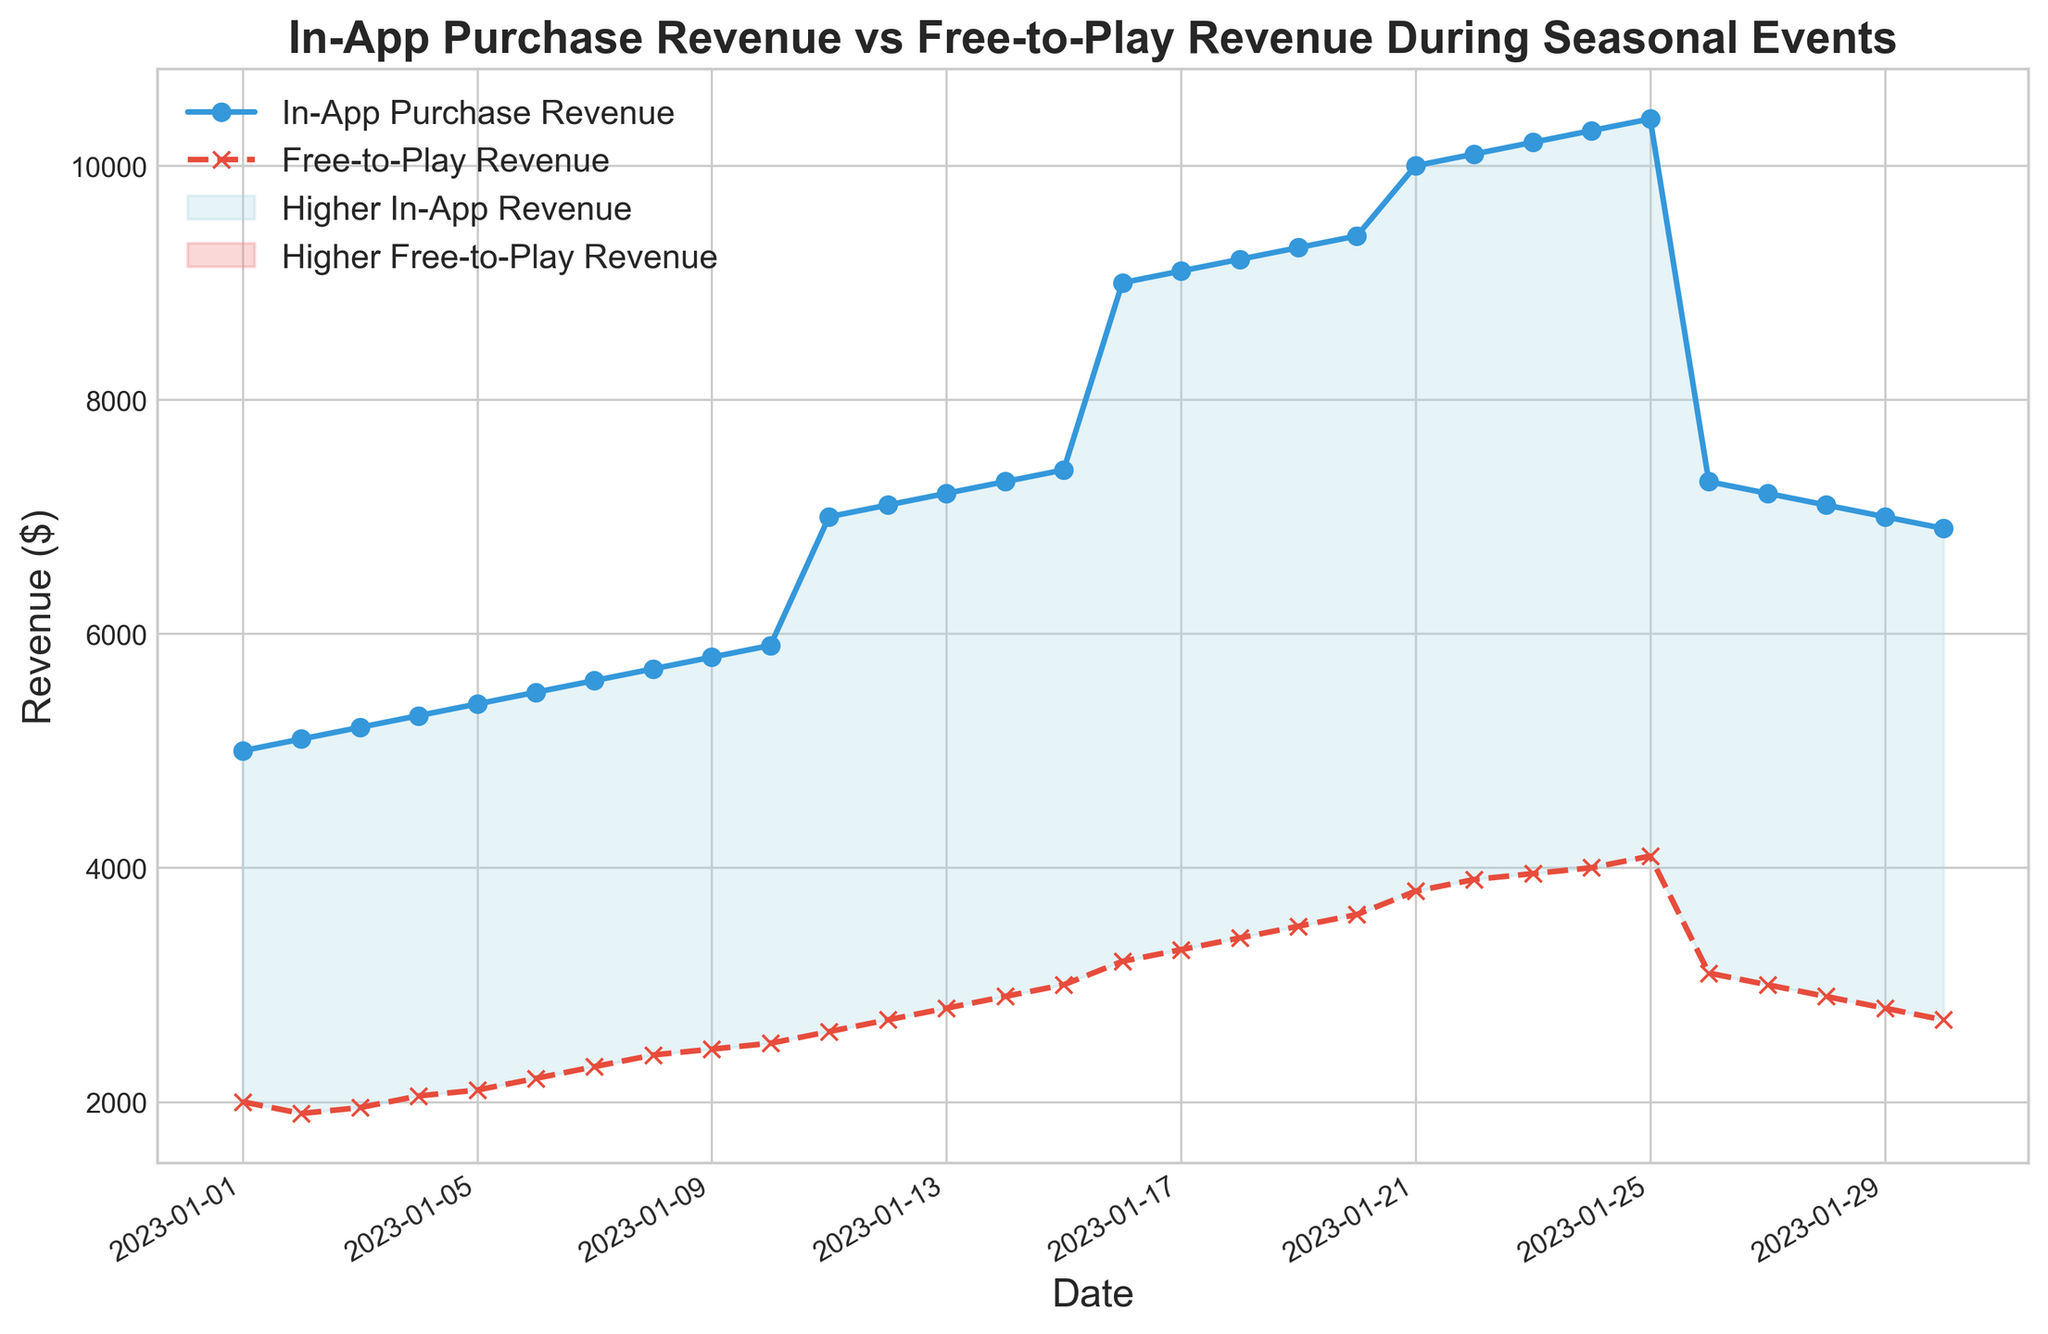What is the highest in-app purchase revenue recorded during the period? The highest point on the in-app purchase revenue line represents the maximum revenue. This occurs on January 24th with a revenue of $10,300.
Answer: $10,300 What is the total revenue from both in-app purchases and free-to-play on January 21st? To find the total revenue for January 21st, sum the in-app purchase revenue and the free-to-play revenue for that date. The in-app purchase revenue is $10,000, and the free-to-play revenue is $3,800. So, the total revenue is $10,000 + $3,800 = $13,800.
Answer: $13,800 On which dates does the in-app purchase revenue exceed the free-to-play revenue by the greatest amount? The greatest difference is visually where the blue shaded area between the lines is widest. This appears around January 16th to January 25th. For instance, on January 24th, the in-app purchase revenue is $10,300 and the free-to-play revenue is $4,000, yielding a difference of $6,300.
Answer: January 24th For how many days did free-to-play revenue decrease consecutively after January 26th? From January 26th onwards, the free-to-play revenue starts decreasing day by day. Specifically, it decreases from January 26th ($3,100) to January 30th ($2,700), making it a decline over 5 consecutive days.
Answer: 5 days How does the average in-app purchase revenue compare to the average free-to-play revenue over the entire period? To find the averages, sum the total in-app purchase revenue and total free-to-play revenue, then divide by the number of days. The total in-app purchase is $210,200 over 30 days, so the average is $210,200 / 30 = $7,007. The total free-to-play revenue is $95,650 over 30 days, so the average is $95,650 / 30 = $3,188. The in-app purchase revenue has a higher average.
Answer: In-app purchase revenue has a higher average What visual element indicates which revenue type is greater on a given day? The area fille between the lines uses shading. Light blue indicates days where in-app purchase revenue is higher, while light red indicates days where free-to-play revenue is higher.
Answer: Shaded area How does the revenue trend for in-app purchases change around the middle of the month? The in-app purchase revenue shows a noticeable increase starting from mid-month, particularly around January 11th, where it climbs rapidly until peaking on January 24th. This upward trend coincides with a significant seasonal event peak.
Answer: Increases around the middle of the month Between which two dates is there a sharp drop in in-app purchase revenue? After January 25th, there is a sharp decrease in in-app purchase revenue, as seen from $10,400 on January 25th to $7,300 on January 26th. This is visually represented by a steep drop in the line chart.
Answer: January 25th to January 26th 